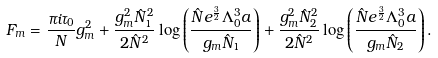<formula> <loc_0><loc_0><loc_500><loc_500>F _ { m } = \frac { \pi i \tau _ { 0 } } { N } g _ { m } ^ { 2 } + \frac { g _ { m } ^ { 2 } \hat { N } _ { 1 } ^ { 2 } } { 2 \hat { N } ^ { 2 } } \log \left ( \frac { \hat { N } e ^ { \frac { 3 } 2 } \Lambda _ { 0 } ^ { 3 } a } { g _ { m } \hat { N } _ { 1 } } \right ) + \frac { g _ { m } ^ { 2 } \hat { N } _ { 2 } ^ { 2 } } { 2 \hat { N } ^ { 2 } } \log \left ( \frac { \hat { N } e ^ { \frac { 3 } 2 } \Lambda _ { 0 } ^ { 3 } a } { g _ { m } \hat { N } _ { 2 } } \right ) .</formula> 